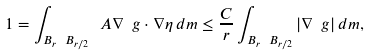Convert formula to latex. <formula><loc_0><loc_0><loc_500><loc_500>1 = \int _ { B _ { r } \ B _ { r / 2 } } \ A \nabla \ g \cdot \nabla \eta \, d m \leq \frac { C } { r } \int _ { B _ { r } \ B _ { r / 2 } } | \nabla \ g | \, d m ,</formula> 